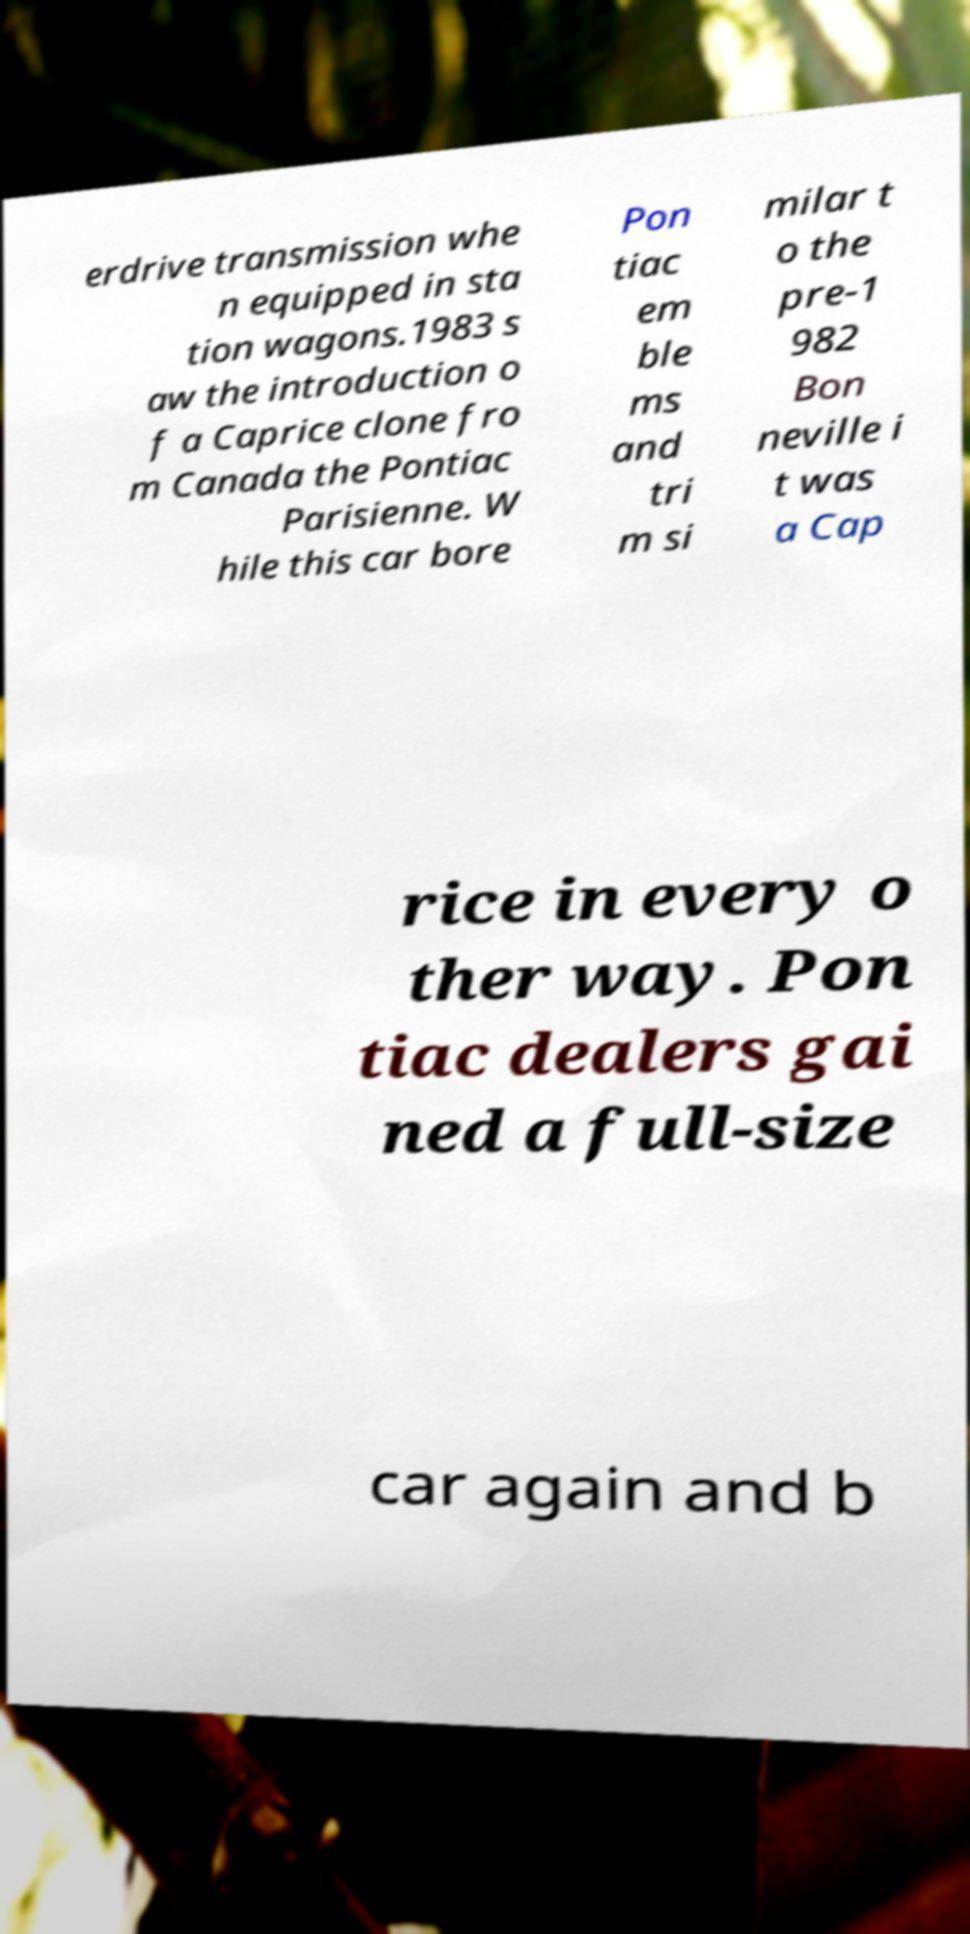For documentation purposes, I need the text within this image transcribed. Could you provide that? erdrive transmission whe n equipped in sta tion wagons.1983 s aw the introduction o f a Caprice clone fro m Canada the Pontiac Parisienne. W hile this car bore Pon tiac em ble ms and tri m si milar t o the pre-1 982 Bon neville i t was a Cap rice in every o ther way. Pon tiac dealers gai ned a full-size car again and b 